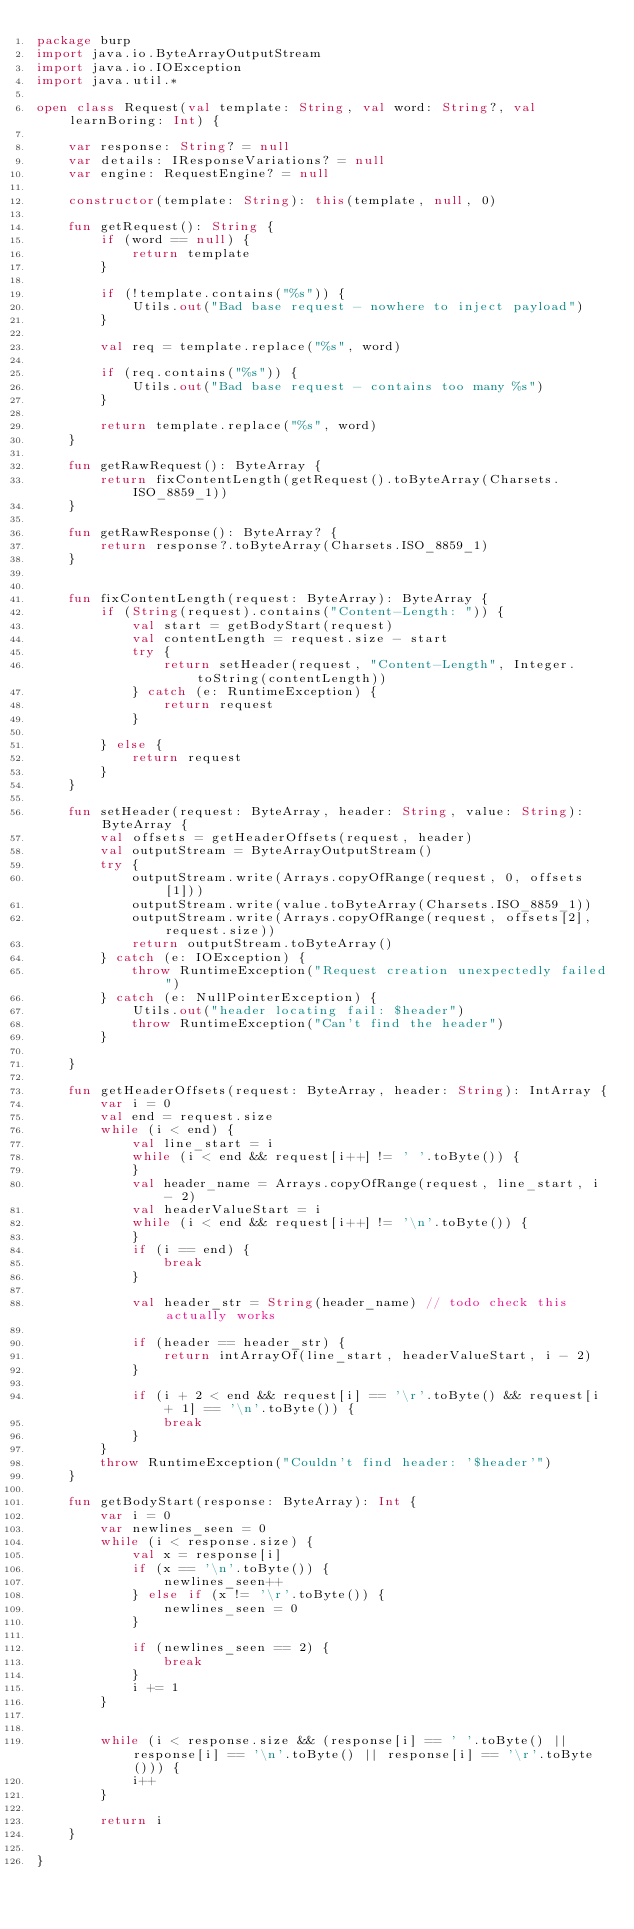Convert code to text. <code><loc_0><loc_0><loc_500><loc_500><_Kotlin_>package burp
import java.io.ByteArrayOutputStream
import java.io.IOException
import java.util.*

open class Request(val template: String, val word: String?, val learnBoring: Int) {

    var response: String? = null
    var details: IResponseVariations? = null
    var engine: RequestEngine? = null

    constructor(template: String): this(template, null, 0)

    fun getRequest(): String {
        if (word == null) {
            return template
        }

        if (!template.contains("%s")) {
            Utils.out("Bad base request - nowhere to inject payload")
        }

        val req = template.replace("%s", word)

        if (req.contains("%s")) {
            Utils.out("Bad base request - contains too many %s")
        }

        return template.replace("%s", word)
    }

    fun getRawRequest(): ByteArray {
        return fixContentLength(getRequest().toByteArray(Charsets.ISO_8859_1))
    }

    fun getRawResponse(): ByteArray? {
        return response?.toByteArray(Charsets.ISO_8859_1)
    }


    fun fixContentLength(request: ByteArray): ByteArray {
        if (String(request).contains("Content-Length: ")) {
            val start = getBodyStart(request)
            val contentLength = request.size - start
            try {
                return setHeader(request, "Content-Length", Integer.toString(contentLength))
            } catch (e: RuntimeException) {
                return request
            }

        } else {
            return request
        }
    }

    fun setHeader(request: ByteArray, header: String, value: String): ByteArray {
        val offsets = getHeaderOffsets(request, header)
        val outputStream = ByteArrayOutputStream()
        try {
            outputStream.write(Arrays.copyOfRange(request, 0, offsets[1]))
            outputStream.write(value.toByteArray(Charsets.ISO_8859_1))
            outputStream.write(Arrays.copyOfRange(request, offsets[2], request.size))
            return outputStream.toByteArray()
        } catch (e: IOException) {
            throw RuntimeException("Request creation unexpectedly failed")
        } catch (e: NullPointerException) {
            Utils.out("header locating fail: $header")
            throw RuntimeException("Can't find the header")
        }

    }

    fun getHeaderOffsets(request: ByteArray, header: String): IntArray {
        var i = 0
        val end = request.size
        while (i < end) {
            val line_start = i
            while (i < end && request[i++] != ' '.toByte()) {
            }
            val header_name = Arrays.copyOfRange(request, line_start, i - 2)
            val headerValueStart = i
            while (i < end && request[i++] != '\n'.toByte()) {
            }
            if (i == end) {
                break
            }

            val header_str = String(header_name) // todo check this actually works

            if (header == header_str) {
                return intArrayOf(line_start, headerValueStart, i - 2)
            }

            if (i + 2 < end && request[i] == '\r'.toByte() && request[i + 1] == '\n'.toByte()) {
                break
            }
        }
        throw RuntimeException("Couldn't find header: '$header'")
    }

    fun getBodyStart(response: ByteArray): Int {
        var i = 0
        var newlines_seen = 0
        while (i < response.size) {
            val x = response[i]
            if (x == '\n'.toByte()) {
                newlines_seen++
            } else if (x != '\r'.toByte()) {
                newlines_seen = 0
            }

            if (newlines_seen == 2) {
                break
            }
            i += 1
        }


        while (i < response.size && (response[i] == ' '.toByte() || response[i] == '\n'.toByte() || response[i] == '\r'.toByte())) {
            i++
        }

        return i
    }

}</code> 